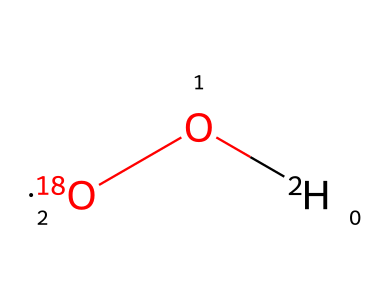What are the isotopes present in this chemical? The chemical displays the presence of two isotopes: oxygen-18 and hydrogen-2 (deuterium). The notation indicates that one oxygen atom is specifically the isotope with 18 nucleons, and one hydrogen atom is the isotope with 2 nucleons.
Answer: oxygen-18 and hydrogen-2 How many total atoms are in this chemical? The representation shows one oxygen atom and two hydrogen atoms, totaling three atoms. When adding the number of hydrogen and oxygen atoms together (2 + 1), it results in three.
Answer: three What type of molecule is represented by this structure? The composition of this chemical suggests that it is a water molecule, as it has two hydrogen atoms bonded to one oxygen atom, resembling the structure of water (H2O). However, it's specifically indicating that it is an isotopically enriched form due to the isotopes.
Answer: water Which isotope affects the density of the rainwater? The density of rainwater can be affected primarily by oxygen-18 because this heavier isotope increases the overall mass of the water molecule. The presence of deuterium (hydrogen-2) also contributes but to a lesser extent.
Answer: oxygen-18 How does the isotopic ratio impact the pH of rainwater? The isotopic ratio influences the pH because different isotopes can alter the dissociation of water, influencing the concentration of hydrogen ions, thus affecting the pH level. Isotopes of hydrogen like deuterium can have slightly different behavior in acid-base reactions than protium due to their mass difference, leading to variations in pH.
Answer: isotopic ratio What is the effect of hydrogen-2 on evaporation rates? Hydrogen-2, being heavier than regular hydrogen (protium), results in slower evaporation rates for compounds containing deuterium. This is because heavier isotopes require more energy to escape into vapor compared to lighter isotopes. The retention of moisture could therefore be higher if there are larger amounts of hydrogen-2 present.
Answer: slower evaporation rates 